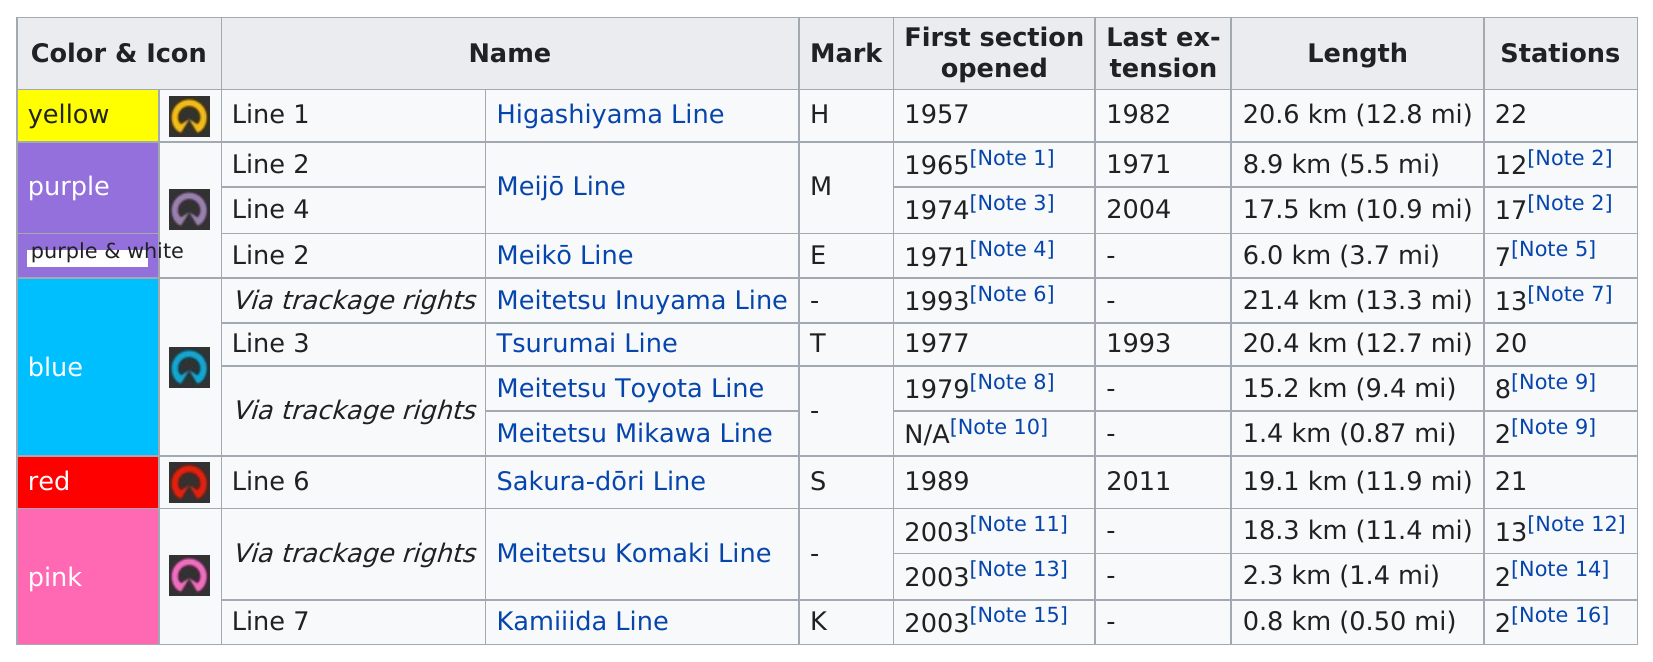List a handful of essential elements in this visual. The color of the last line on this chart was pink. There are 7 lines that have been opened without any extensions being listed. The Higashiyama Line has the most stations among all the lines. The difference in the number of stations available between the Higashiyama Line and the Kamiida Line is 20. The earliest first line was created in 1957. 